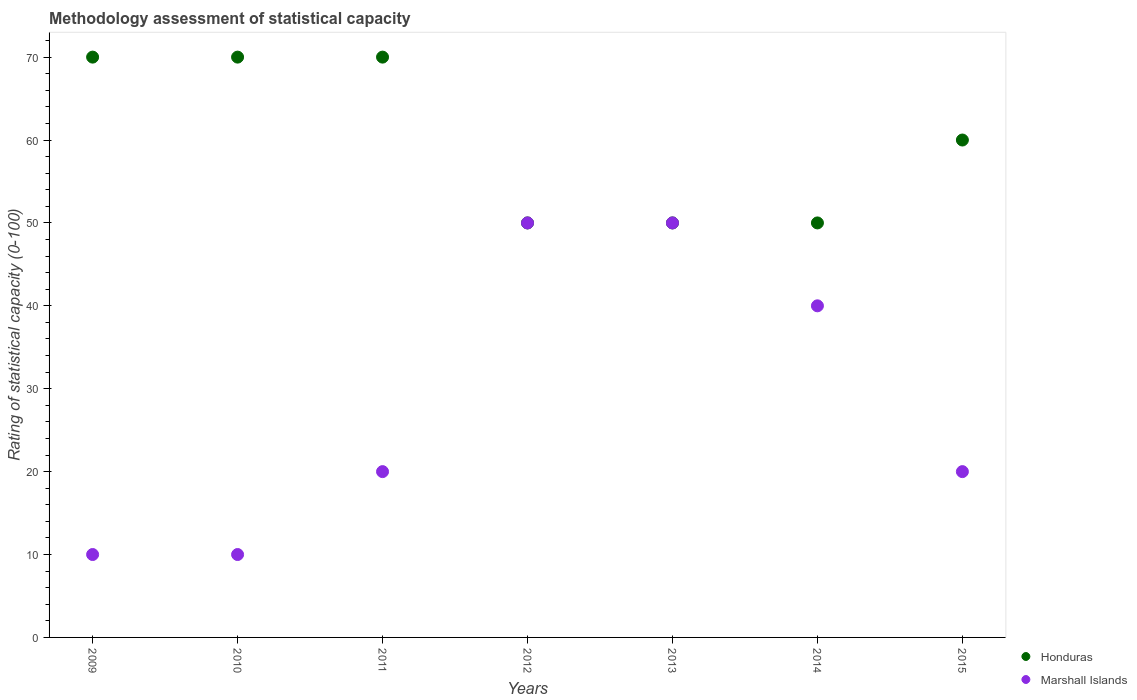Is the number of dotlines equal to the number of legend labels?
Provide a short and direct response. Yes. What is the rating of statistical capacity in Honduras in 2014?
Provide a short and direct response. 50. Across all years, what is the minimum rating of statistical capacity in Honduras?
Make the answer very short. 50. What is the total rating of statistical capacity in Honduras in the graph?
Your answer should be very brief. 420. What is the difference between the rating of statistical capacity in Honduras in 2009 and that in 2014?
Your answer should be compact. 20. What is the difference between the rating of statistical capacity in Marshall Islands in 2010 and the rating of statistical capacity in Honduras in 2009?
Your answer should be very brief. -60. What is the average rating of statistical capacity in Honduras per year?
Ensure brevity in your answer.  60. What is the ratio of the rating of statistical capacity in Marshall Islands in 2014 to that in 2015?
Provide a short and direct response. 2. Is the rating of statistical capacity in Honduras in 2010 less than that in 2013?
Offer a terse response. No. Is the difference between the rating of statistical capacity in Honduras in 2011 and 2015 greater than the difference between the rating of statistical capacity in Marshall Islands in 2011 and 2015?
Provide a short and direct response. Yes. What is the difference between the highest and the second highest rating of statistical capacity in Marshall Islands?
Keep it short and to the point. 0. In how many years, is the rating of statistical capacity in Honduras greater than the average rating of statistical capacity in Honduras taken over all years?
Make the answer very short. 3. Is the sum of the rating of statistical capacity in Marshall Islands in 2009 and 2014 greater than the maximum rating of statistical capacity in Honduras across all years?
Provide a succinct answer. No. Does the rating of statistical capacity in Marshall Islands monotonically increase over the years?
Your answer should be compact. No. Is the rating of statistical capacity in Honduras strictly greater than the rating of statistical capacity in Marshall Islands over the years?
Keep it short and to the point. No. How many dotlines are there?
Your response must be concise. 2. What is the difference between two consecutive major ticks on the Y-axis?
Offer a very short reply. 10. Are the values on the major ticks of Y-axis written in scientific E-notation?
Give a very brief answer. No. Does the graph contain any zero values?
Your response must be concise. No. Does the graph contain grids?
Make the answer very short. No. Where does the legend appear in the graph?
Provide a succinct answer. Bottom right. How many legend labels are there?
Make the answer very short. 2. What is the title of the graph?
Make the answer very short. Methodology assessment of statistical capacity. What is the label or title of the X-axis?
Keep it short and to the point. Years. What is the label or title of the Y-axis?
Make the answer very short. Rating of statistical capacity (0-100). What is the Rating of statistical capacity (0-100) of Honduras in 2009?
Offer a very short reply. 70. What is the Rating of statistical capacity (0-100) of Honduras in 2010?
Offer a very short reply. 70. What is the Rating of statistical capacity (0-100) in Marshall Islands in 2010?
Keep it short and to the point. 10. What is the Rating of statistical capacity (0-100) of Honduras in 2011?
Provide a short and direct response. 70. What is the Rating of statistical capacity (0-100) in Honduras in 2012?
Provide a short and direct response. 50. What is the Rating of statistical capacity (0-100) in Marshall Islands in 2013?
Ensure brevity in your answer.  50. Across all years, what is the maximum Rating of statistical capacity (0-100) of Honduras?
Your answer should be very brief. 70. Across all years, what is the maximum Rating of statistical capacity (0-100) in Marshall Islands?
Your answer should be very brief. 50. What is the total Rating of statistical capacity (0-100) in Honduras in the graph?
Your response must be concise. 420. What is the difference between the Rating of statistical capacity (0-100) of Honduras in 2009 and that in 2010?
Offer a very short reply. 0. What is the difference between the Rating of statistical capacity (0-100) in Marshall Islands in 2009 and that in 2010?
Offer a very short reply. 0. What is the difference between the Rating of statistical capacity (0-100) in Honduras in 2009 and that in 2011?
Ensure brevity in your answer.  0. What is the difference between the Rating of statistical capacity (0-100) in Marshall Islands in 2009 and that in 2011?
Make the answer very short. -10. What is the difference between the Rating of statistical capacity (0-100) of Marshall Islands in 2009 and that in 2012?
Keep it short and to the point. -40. What is the difference between the Rating of statistical capacity (0-100) in Honduras in 2009 and that in 2013?
Give a very brief answer. 20. What is the difference between the Rating of statistical capacity (0-100) of Honduras in 2009 and that in 2014?
Give a very brief answer. 20. What is the difference between the Rating of statistical capacity (0-100) in Marshall Islands in 2009 and that in 2014?
Provide a short and direct response. -30. What is the difference between the Rating of statistical capacity (0-100) of Honduras in 2009 and that in 2015?
Your response must be concise. 10. What is the difference between the Rating of statistical capacity (0-100) in Marshall Islands in 2009 and that in 2015?
Your answer should be compact. -10. What is the difference between the Rating of statistical capacity (0-100) in Honduras in 2010 and that in 2011?
Offer a terse response. 0. What is the difference between the Rating of statistical capacity (0-100) of Marshall Islands in 2010 and that in 2011?
Offer a very short reply. -10. What is the difference between the Rating of statistical capacity (0-100) of Honduras in 2010 and that in 2012?
Give a very brief answer. 20. What is the difference between the Rating of statistical capacity (0-100) in Honduras in 2010 and that in 2013?
Provide a succinct answer. 20. What is the difference between the Rating of statistical capacity (0-100) of Marshall Islands in 2010 and that in 2014?
Your response must be concise. -30. What is the difference between the Rating of statistical capacity (0-100) in Honduras in 2011 and that in 2012?
Your answer should be very brief. 20. What is the difference between the Rating of statistical capacity (0-100) in Marshall Islands in 2011 and that in 2012?
Your answer should be very brief. -30. What is the difference between the Rating of statistical capacity (0-100) of Marshall Islands in 2011 and that in 2013?
Give a very brief answer. -30. What is the difference between the Rating of statistical capacity (0-100) of Marshall Islands in 2011 and that in 2014?
Your response must be concise. -20. What is the difference between the Rating of statistical capacity (0-100) in Honduras in 2011 and that in 2015?
Provide a succinct answer. 10. What is the difference between the Rating of statistical capacity (0-100) in Marshall Islands in 2011 and that in 2015?
Offer a terse response. 0. What is the difference between the Rating of statistical capacity (0-100) in Honduras in 2012 and that in 2013?
Offer a terse response. 0. What is the difference between the Rating of statistical capacity (0-100) in Marshall Islands in 2012 and that in 2013?
Offer a very short reply. 0. What is the difference between the Rating of statistical capacity (0-100) in Honduras in 2012 and that in 2014?
Your answer should be compact. 0. What is the difference between the Rating of statistical capacity (0-100) in Honduras in 2013 and that in 2015?
Your answer should be compact. -10. What is the difference between the Rating of statistical capacity (0-100) in Honduras in 2014 and that in 2015?
Your answer should be compact. -10. What is the difference between the Rating of statistical capacity (0-100) of Marshall Islands in 2014 and that in 2015?
Provide a succinct answer. 20. What is the difference between the Rating of statistical capacity (0-100) of Honduras in 2009 and the Rating of statistical capacity (0-100) of Marshall Islands in 2012?
Offer a very short reply. 20. What is the difference between the Rating of statistical capacity (0-100) in Honduras in 2009 and the Rating of statistical capacity (0-100) in Marshall Islands in 2013?
Your answer should be very brief. 20. What is the difference between the Rating of statistical capacity (0-100) of Honduras in 2009 and the Rating of statistical capacity (0-100) of Marshall Islands in 2014?
Offer a very short reply. 30. What is the difference between the Rating of statistical capacity (0-100) in Honduras in 2010 and the Rating of statistical capacity (0-100) in Marshall Islands in 2011?
Offer a very short reply. 50. What is the difference between the Rating of statistical capacity (0-100) of Honduras in 2010 and the Rating of statistical capacity (0-100) of Marshall Islands in 2012?
Make the answer very short. 20. What is the difference between the Rating of statistical capacity (0-100) in Honduras in 2010 and the Rating of statistical capacity (0-100) in Marshall Islands in 2013?
Your answer should be very brief. 20. What is the difference between the Rating of statistical capacity (0-100) of Honduras in 2011 and the Rating of statistical capacity (0-100) of Marshall Islands in 2012?
Make the answer very short. 20. What is the difference between the Rating of statistical capacity (0-100) in Honduras in 2011 and the Rating of statistical capacity (0-100) in Marshall Islands in 2015?
Provide a succinct answer. 50. What is the difference between the Rating of statistical capacity (0-100) in Honduras in 2012 and the Rating of statistical capacity (0-100) in Marshall Islands in 2013?
Provide a short and direct response. 0. What is the difference between the Rating of statistical capacity (0-100) in Honduras in 2013 and the Rating of statistical capacity (0-100) in Marshall Islands in 2015?
Make the answer very short. 30. What is the difference between the Rating of statistical capacity (0-100) in Honduras in 2014 and the Rating of statistical capacity (0-100) in Marshall Islands in 2015?
Your answer should be compact. 30. What is the average Rating of statistical capacity (0-100) of Marshall Islands per year?
Provide a short and direct response. 28.57. In the year 2009, what is the difference between the Rating of statistical capacity (0-100) of Honduras and Rating of statistical capacity (0-100) of Marshall Islands?
Your answer should be very brief. 60. In the year 2010, what is the difference between the Rating of statistical capacity (0-100) in Honduras and Rating of statistical capacity (0-100) in Marshall Islands?
Give a very brief answer. 60. In the year 2012, what is the difference between the Rating of statistical capacity (0-100) in Honduras and Rating of statistical capacity (0-100) in Marshall Islands?
Your answer should be compact. 0. In the year 2015, what is the difference between the Rating of statistical capacity (0-100) of Honduras and Rating of statistical capacity (0-100) of Marshall Islands?
Provide a succinct answer. 40. What is the ratio of the Rating of statistical capacity (0-100) in Honduras in 2009 to that in 2011?
Provide a succinct answer. 1. What is the ratio of the Rating of statistical capacity (0-100) of Marshall Islands in 2009 to that in 2011?
Offer a very short reply. 0.5. What is the ratio of the Rating of statistical capacity (0-100) in Marshall Islands in 2009 to that in 2014?
Offer a terse response. 0.25. What is the ratio of the Rating of statistical capacity (0-100) of Marshall Islands in 2009 to that in 2015?
Your response must be concise. 0.5. What is the ratio of the Rating of statistical capacity (0-100) in Honduras in 2010 to that in 2011?
Your answer should be very brief. 1. What is the ratio of the Rating of statistical capacity (0-100) in Honduras in 2010 to that in 2012?
Provide a succinct answer. 1.4. What is the ratio of the Rating of statistical capacity (0-100) of Honduras in 2010 to that in 2013?
Keep it short and to the point. 1.4. What is the ratio of the Rating of statistical capacity (0-100) of Honduras in 2011 to that in 2012?
Provide a short and direct response. 1.4. What is the ratio of the Rating of statistical capacity (0-100) in Marshall Islands in 2011 to that in 2012?
Keep it short and to the point. 0.4. What is the ratio of the Rating of statistical capacity (0-100) in Honduras in 2011 to that in 2013?
Offer a terse response. 1.4. What is the ratio of the Rating of statistical capacity (0-100) in Marshall Islands in 2011 to that in 2013?
Your answer should be very brief. 0.4. What is the ratio of the Rating of statistical capacity (0-100) in Honduras in 2012 to that in 2014?
Keep it short and to the point. 1. What is the ratio of the Rating of statistical capacity (0-100) of Marshall Islands in 2012 to that in 2014?
Offer a terse response. 1.25. What is the ratio of the Rating of statistical capacity (0-100) in Marshall Islands in 2013 to that in 2014?
Offer a very short reply. 1.25. What is the ratio of the Rating of statistical capacity (0-100) of Honduras in 2014 to that in 2015?
Keep it short and to the point. 0.83. What is the difference between the highest and the second highest Rating of statistical capacity (0-100) of Marshall Islands?
Make the answer very short. 0. 